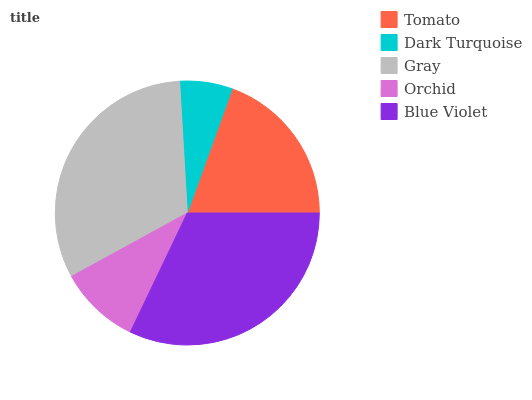Is Dark Turquoise the minimum?
Answer yes or no. Yes. Is Blue Violet the maximum?
Answer yes or no. Yes. Is Gray the minimum?
Answer yes or no. No. Is Gray the maximum?
Answer yes or no. No. Is Gray greater than Dark Turquoise?
Answer yes or no. Yes. Is Dark Turquoise less than Gray?
Answer yes or no. Yes. Is Dark Turquoise greater than Gray?
Answer yes or no. No. Is Gray less than Dark Turquoise?
Answer yes or no. No. Is Tomato the high median?
Answer yes or no. Yes. Is Tomato the low median?
Answer yes or no. Yes. Is Orchid the high median?
Answer yes or no. No. Is Orchid the low median?
Answer yes or no. No. 